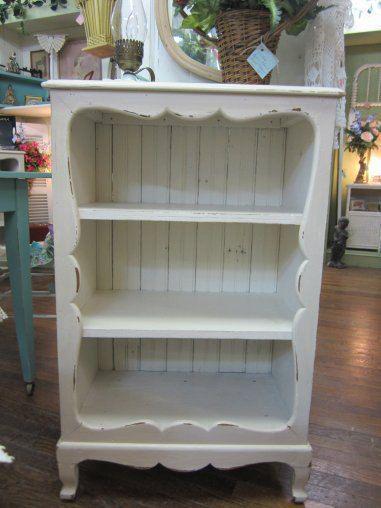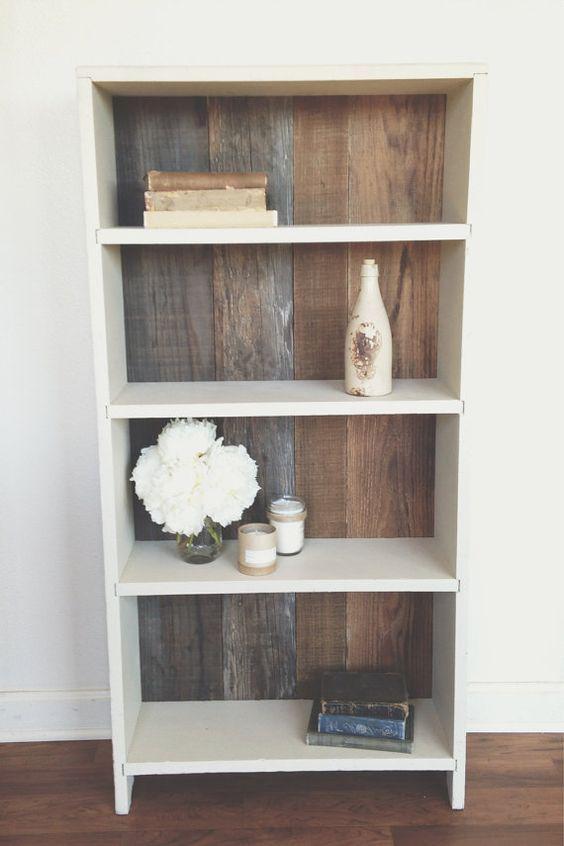The first image is the image on the left, the second image is the image on the right. Examine the images to the left and right. Is the description "One of the cabinets has doors." accurate? Answer yes or no. No. The first image is the image on the left, the second image is the image on the right. Analyze the images presented: Is the assertion "At least one shelving unit is teal." valid? Answer yes or no. No. 